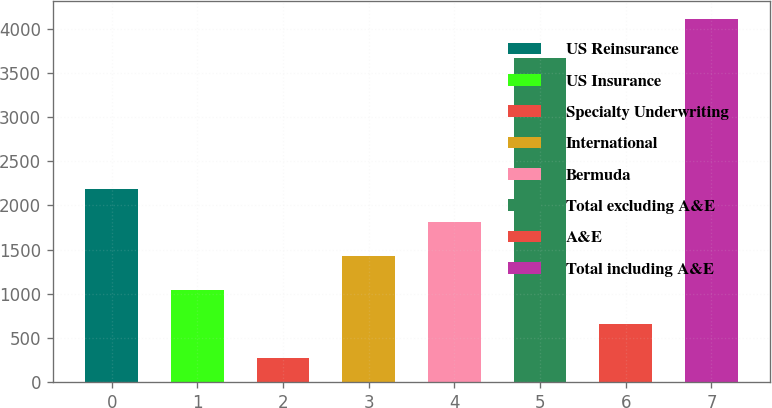<chart> <loc_0><loc_0><loc_500><loc_500><bar_chart><fcel>US Reinsurance<fcel>US Insurance<fcel>Specialty Underwriting<fcel>International<fcel>Bermuda<fcel>Total excluding A&E<fcel>A&E<fcel>Total including A&E<nl><fcel>2191.5<fcel>1040.52<fcel>273.2<fcel>1424.18<fcel>1807.84<fcel>3670<fcel>656.86<fcel>4109.8<nl></chart> 